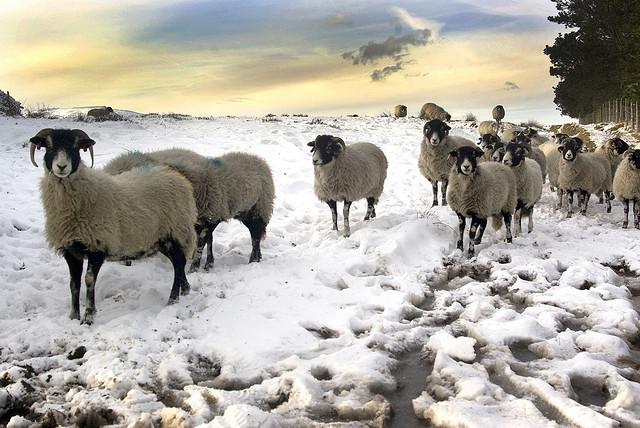Are the sheep looking at the camera?
Short answer required. Yes. Where are they going?
Keep it brief. Home. Is it cold?
Keep it brief. Yes. 